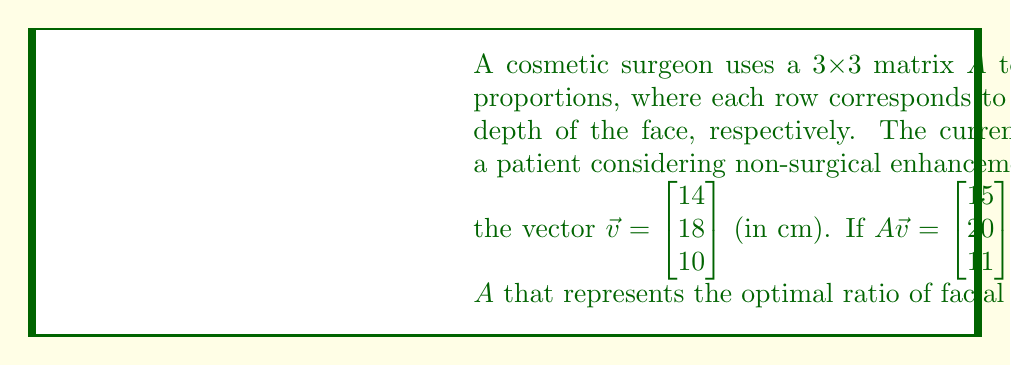Give your solution to this math problem. To find the matrix $A$, we need to solve the equation $A\vec{v} = \begin{bmatrix} 15 \\ 20 \\ 11 \end{bmatrix}$.

Let $A = \begin{bmatrix} a_{11} & a_{12} & a_{13} \\ a_{21} & a_{22} & a_{23} \\ a_{31} & a_{32} & a_{33} \end{bmatrix}$

Step 1: Write out the matrix equation:
$$\begin{bmatrix} a_{11} & a_{12} & a_{13} \\ a_{21} & a_{22} & a_{23} \\ a_{31} & a_{32} & a_{33} \end{bmatrix} \begin{bmatrix} 14 \\ 18 \\ 10 \end{bmatrix} = \begin{bmatrix} 15 \\ 20 \\ 11 \end{bmatrix}$$

Step 2: Multiply the matrices:
$$\begin{bmatrix} 14a_{11} + 18a_{12} + 10a_{13} \\ 14a_{21} + 18a_{22} + 10a_{23} \\ 14a_{31} + 18a_{32} + 10a_{33} \end{bmatrix} = \begin{bmatrix} 15 \\ 20 \\ 11 \end{bmatrix}$$

Step 3: Set up three equations:
1) $14a_{11} + 18a_{12} + 10a_{13} = 15$
2) $14a_{21} + 18a_{22} + 10a_{23} = 20$
3) $14a_{31} + 18a_{32} + 10a_{33} = 11$

Step 4: Solve each equation for the diagonal element:
1) $a_{11} = \frac{15 - 18a_{12} - 10a_{13}}{14}$
2) $a_{22} = \frac{20 - 14a_{21} - 10a_{23}}{18}$
3) $a_{33} = \frac{11 - 14a_{31} - 18a_{32}}{10}$

Step 5: To find the optimal ratio, we want the non-diagonal elements to be 0, as they represent mixing between different facial dimensions. This gives us:

$a_{11} = \frac{15}{14} \approx 1.0714$
$a_{22} = \frac{20}{18} \approx 1.1111$
$a_{33} = \frac{11}{10} = 1.1$

Therefore, the optimal ratio matrix $A$ is:
$$A = \begin{bmatrix} 1.0714 & 0 & 0 \\ 0 & 1.1111 & 0 \\ 0 & 0 & 1.1 \end{bmatrix}$$
Answer: $$A = \begin{bmatrix} 1.0714 & 0 & 0 \\ 0 & 1.1111 & 0 \\ 0 & 0 & 1.1 \end{bmatrix}$$ 